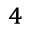<formula> <loc_0><loc_0><loc_500><loc_500>_ { 4 }</formula> 